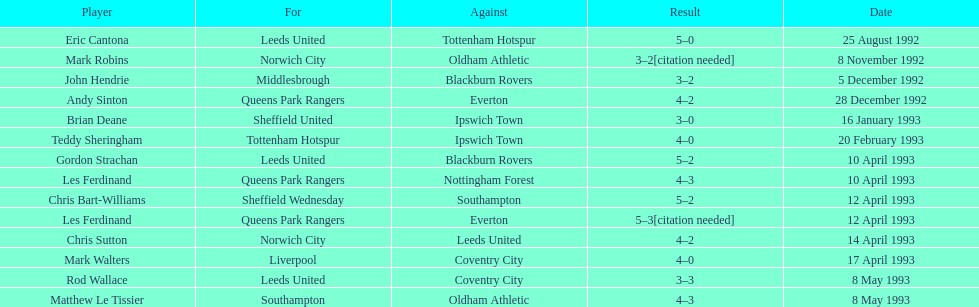What was the conclusion of the match between queens park rangers and everton? 4-2. 